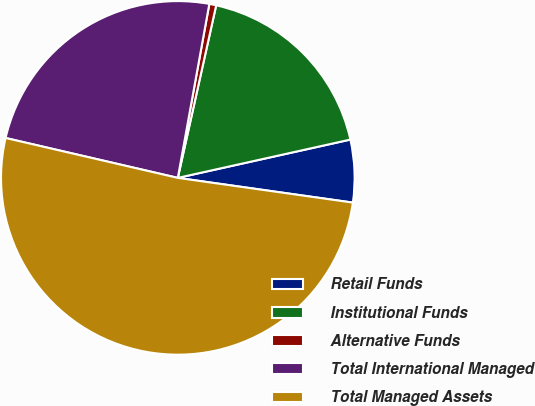<chart> <loc_0><loc_0><loc_500><loc_500><pie_chart><fcel>Retail Funds<fcel>Institutional Funds<fcel>Alternative Funds<fcel>Total International Managed<fcel>Total Managed Assets<nl><fcel>5.71%<fcel>18.04%<fcel>0.63%<fcel>24.23%<fcel>51.39%<nl></chart> 